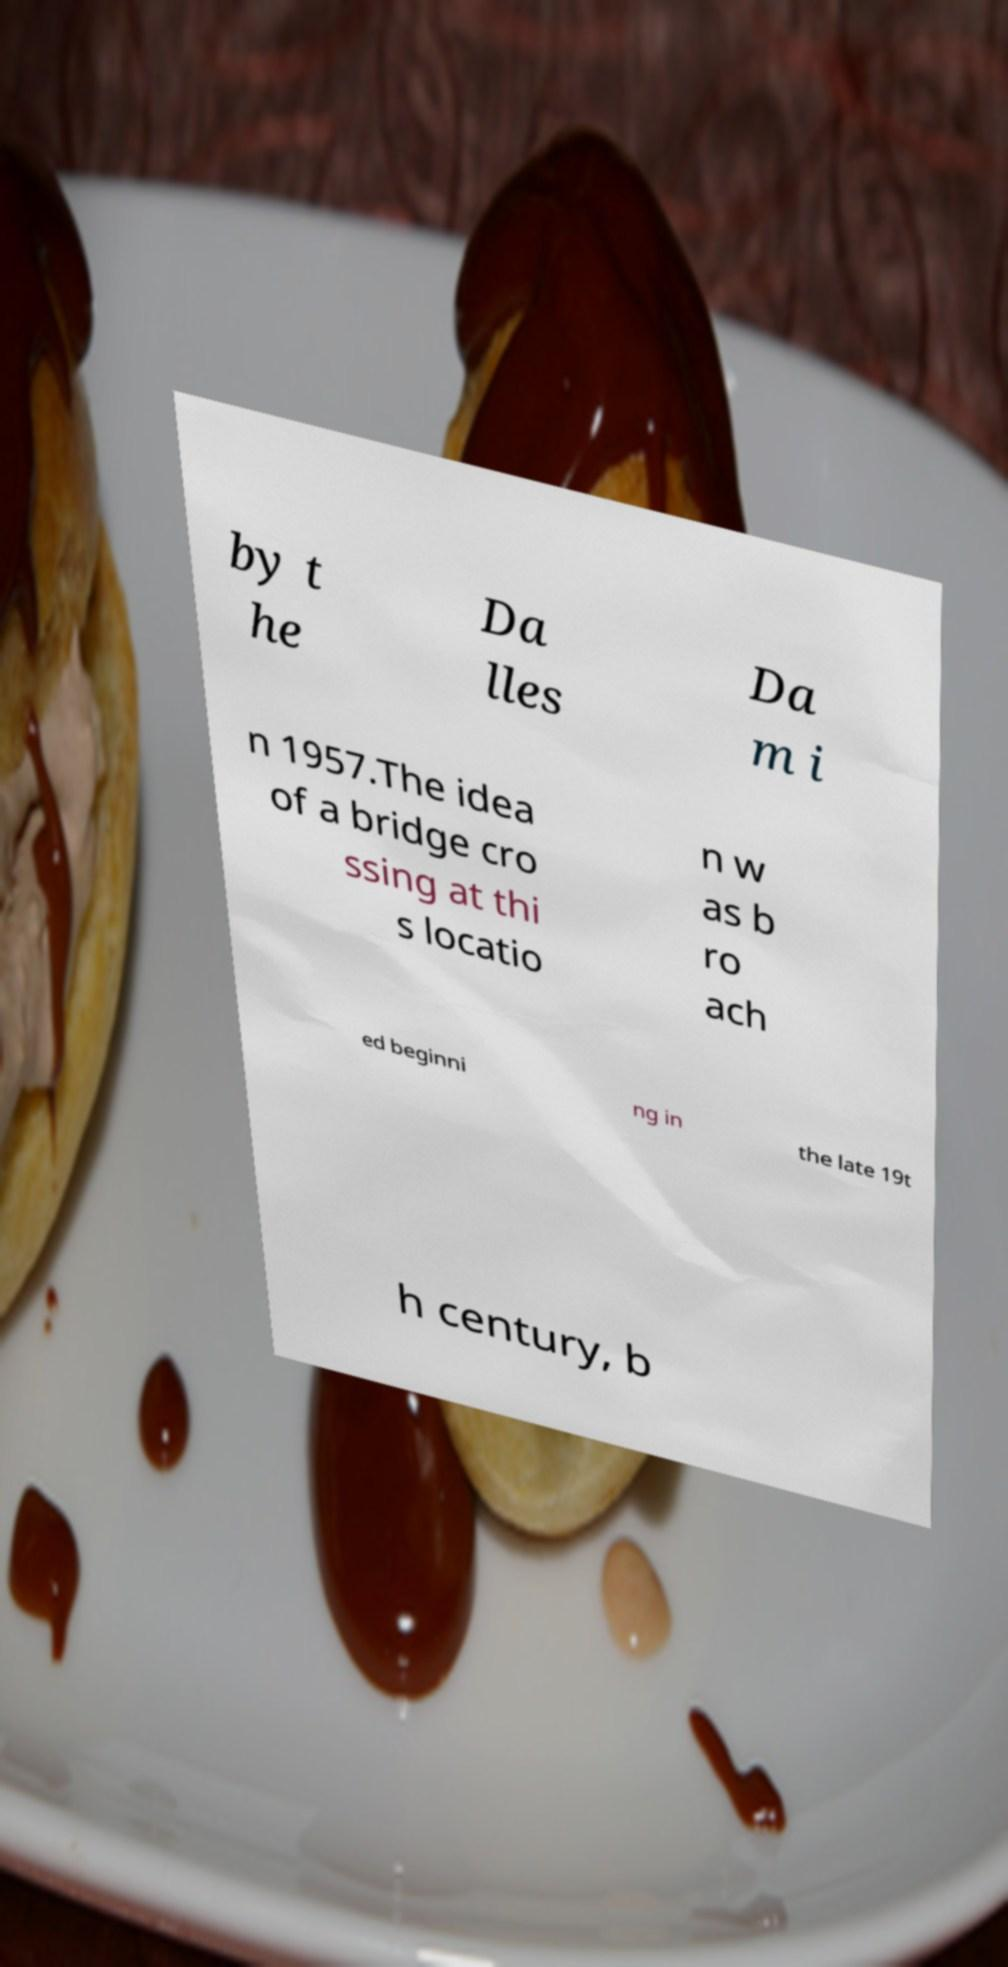Can you accurately transcribe the text from the provided image for me? by t he Da lles Da m i n 1957.The idea of a bridge cro ssing at thi s locatio n w as b ro ach ed beginni ng in the late 19t h century, b 